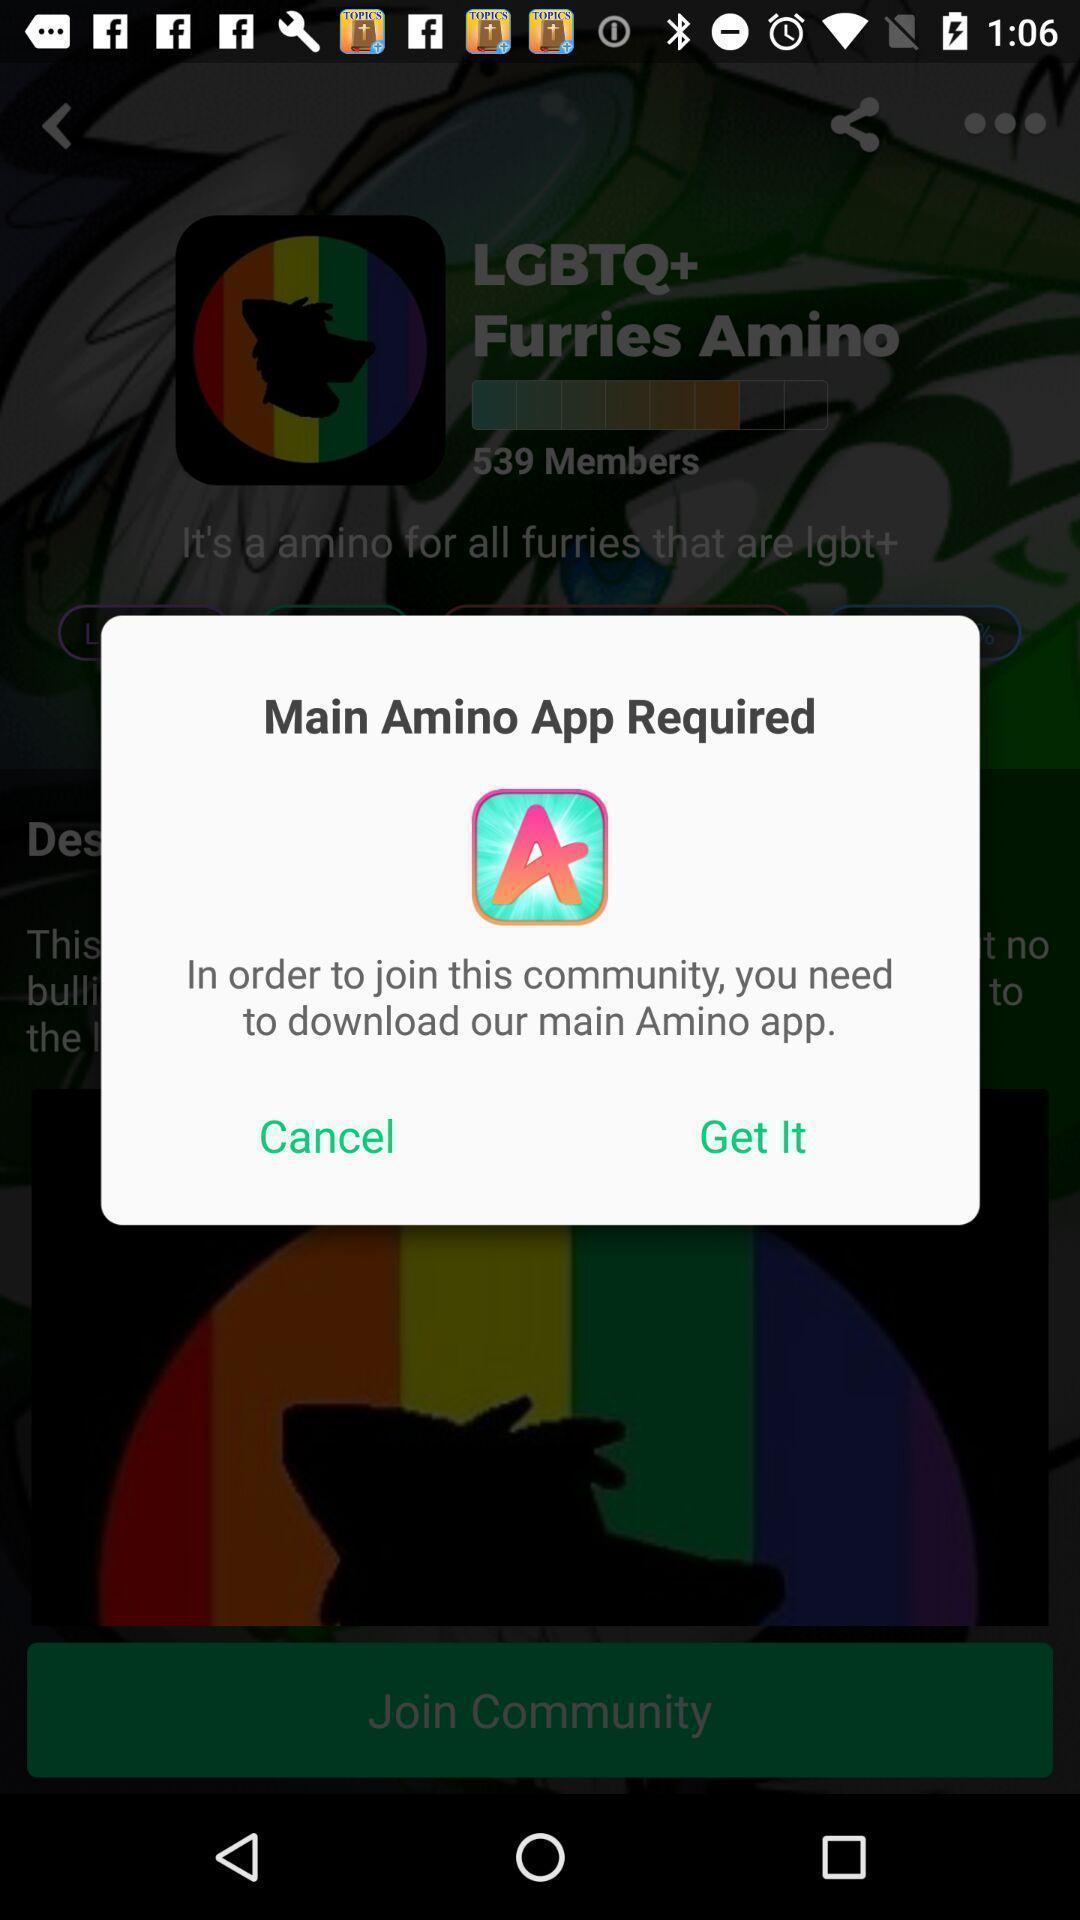Tell me what you see in this picture. Pop-up message to download the app. 